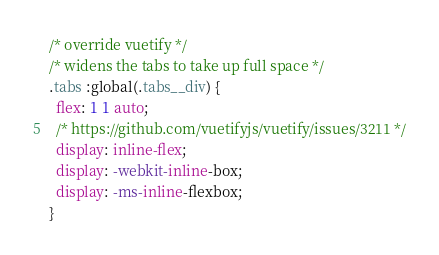Convert code to text. <code><loc_0><loc_0><loc_500><loc_500><_CSS_>/* override vuetify */
/* widens the tabs to take up full space */
.tabs :global(.tabs__div) {
  flex: 1 1 auto;
  /* https://github.com/vuetifyjs/vuetify/issues/3211 */
  display: inline-flex;
  display: -webkit-inline-box;
  display: -ms-inline-flexbox;
}
</code> 